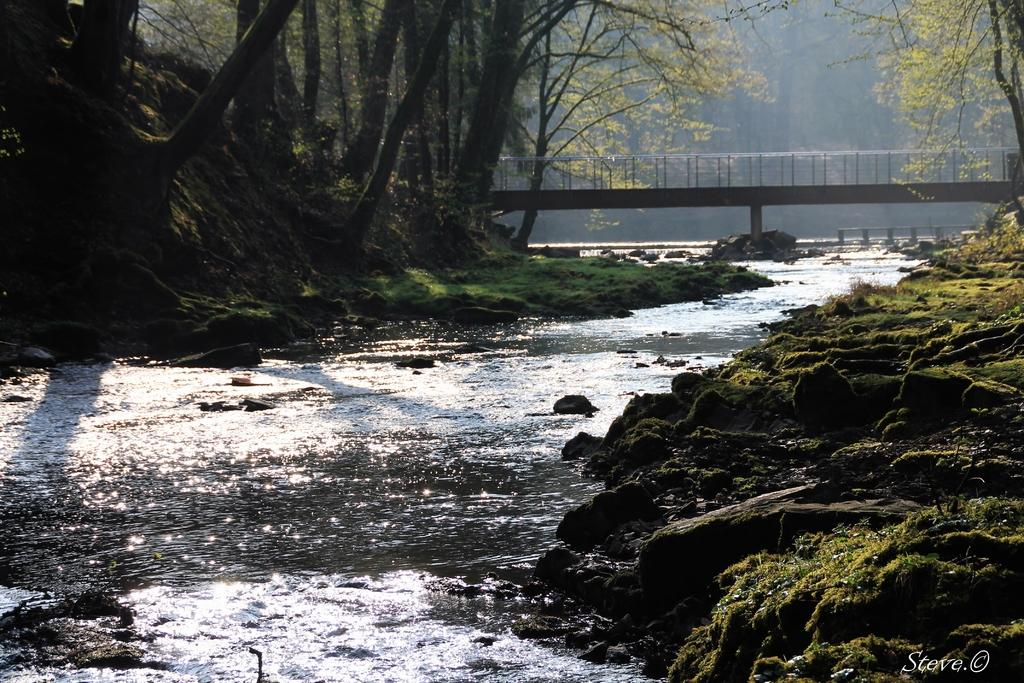What type of structure can be seen in the image? There is a bridge in the image. What type of vegetation is present in the image? There is grass in the image. What natural element is visible in the image? There is water in the image. What type of material is present in the image? There are stones in the image. What can be seen in the background of the image? There are trees in the background of the image. Can you tell me how many judges are present in the image? There are no judges present in the image. Does the existence of the bridge in the image imply the existence of a mouth? The bridge in the image does not imply the existence of a mouth; it is a physical structure. 